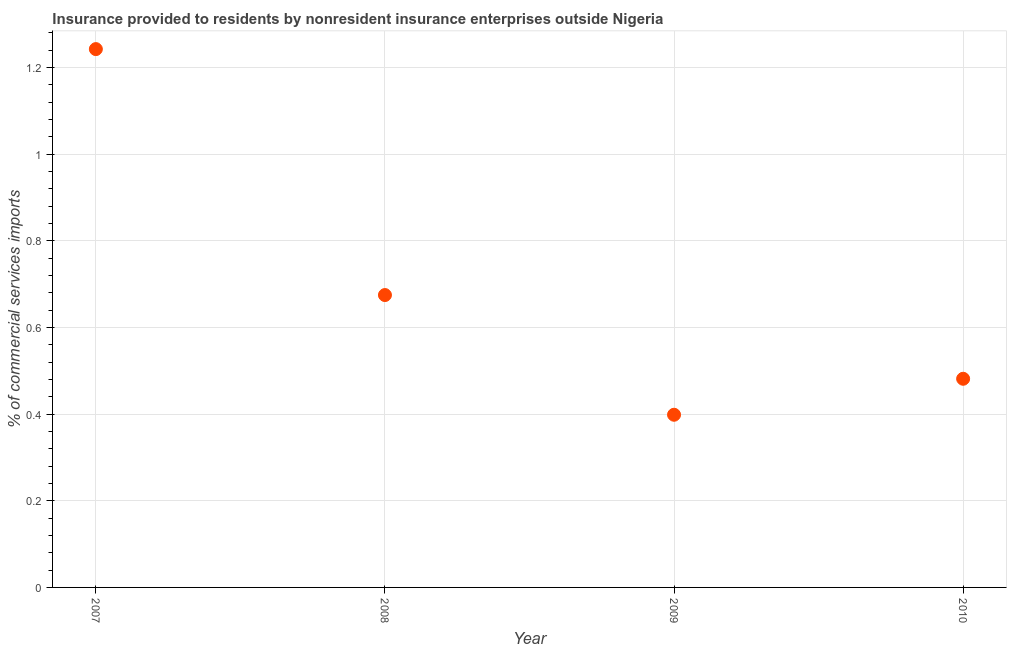What is the insurance provided by non-residents in 2008?
Keep it short and to the point. 0.67. Across all years, what is the maximum insurance provided by non-residents?
Ensure brevity in your answer.  1.24. Across all years, what is the minimum insurance provided by non-residents?
Offer a terse response. 0.4. What is the sum of the insurance provided by non-residents?
Make the answer very short. 2.8. What is the difference between the insurance provided by non-residents in 2007 and 2009?
Provide a short and direct response. 0.84. What is the average insurance provided by non-residents per year?
Make the answer very short. 0.7. What is the median insurance provided by non-residents?
Offer a terse response. 0.58. In how many years, is the insurance provided by non-residents greater than 0.7200000000000001 %?
Keep it short and to the point. 1. What is the ratio of the insurance provided by non-residents in 2007 to that in 2008?
Keep it short and to the point. 1.84. Is the insurance provided by non-residents in 2007 less than that in 2009?
Your answer should be very brief. No. What is the difference between the highest and the second highest insurance provided by non-residents?
Your answer should be very brief. 0.57. Is the sum of the insurance provided by non-residents in 2009 and 2010 greater than the maximum insurance provided by non-residents across all years?
Your response must be concise. No. What is the difference between the highest and the lowest insurance provided by non-residents?
Offer a very short reply. 0.84. In how many years, is the insurance provided by non-residents greater than the average insurance provided by non-residents taken over all years?
Your answer should be compact. 1. How many years are there in the graph?
Keep it short and to the point. 4. What is the difference between two consecutive major ticks on the Y-axis?
Keep it short and to the point. 0.2. Are the values on the major ticks of Y-axis written in scientific E-notation?
Make the answer very short. No. Does the graph contain grids?
Offer a very short reply. Yes. What is the title of the graph?
Your answer should be compact. Insurance provided to residents by nonresident insurance enterprises outside Nigeria. What is the label or title of the X-axis?
Provide a short and direct response. Year. What is the label or title of the Y-axis?
Your response must be concise. % of commercial services imports. What is the % of commercial services imports in 2007?
Your answer should be compact. 1.24. What is the % of commercial services imports in 2008?
Provide a short and direct response. 0.67. What is the % of commercial services imports in 2009?
Offer a very short reply. 0.4. What is the % of commercial services imports in 2010?
Your answer should be very brief. 0.48. What is the difference between the % of commercial services imports in 2007 and 2008?
Ensure brevity in your answer.  0.57. What is the difference between the % of commercial services imports in 2007 and 2009?
Your response must be concise. 0.84. What is the difference between the % of commercial services imports in 2007 and 2010?
Offer a very short reply. 0.76. What is the difference between the % of commercial services imports in 2008 and 2009?
Give a very brief answer. 0.28. What is the difference between the % of commercial services imports in 2008 and 2010?
Your answer should be compact. 0.19. What is the difference between the % of commercial services imports in 2009 and 2010?
Give a very brief answer. -0.08. What is the ratio of the % of commercial services imports in 2007 to that in 2008?
Provide a short and direct response. 1.84. What is the ratio of the % of commercial services imports in 2007 to that in 2009?
Provide a succinct answer. 3.12. What is the ratio of the % of commercial services imports in 2007 to that in 2010?
Keep it short and to the point. 2.58. What is the ratio of the % of commercial services imports in 2008 to that in 2009?
Give a very brief answer. 1.69. What is the ratio of the % of commercial services imports in 2008 to that in 2010?
Your response must be concise. 1.4. What is the ratio of the % of commercial services imports in 2009 to that in 2010?
Offer a terse response. 0.83. 